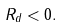Convert formula to latex. <formula><loc_0><loc_0><loc_500><loc_500>R _ { d } < 0 .</formula> 